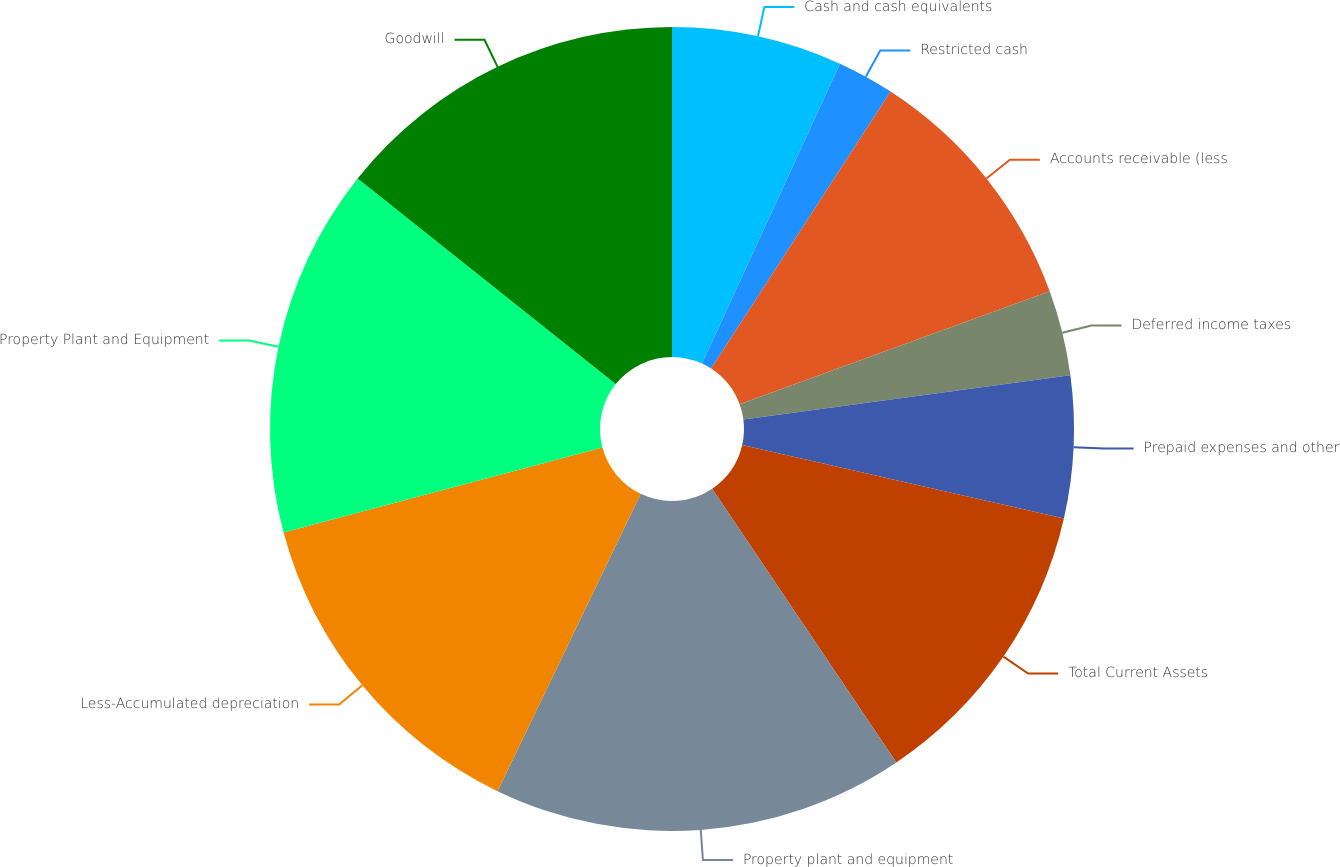<chart> <loc_0><loc_0><loc_500><loc_500><pie_chart><fcel>Cash and cash equivalents<fcel>Restricted cash<fcel>Accounts receivable (less<fcel>Deferred income taxes<fcel>Prepaid expenses and other<fcel>Total Current Assets<fcel>Property plant and equipment<fcel>Less-Accumulated depreciation<fcel>Property Plant and Equipment<fcel>Goodwill<nl><fcel>6.86%<fcel>2.29%<fcel>10.29%<fcel>3.43%<fcel>5.71%<fcel>12.0%<fcel>16.57%<fcel>13.71%<fcel>14.86%<fcel>14.29%<nl></chart> 